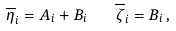<formula> <loc_0><loc_0><loc_500><loc_500>\overline { \eta } _ { i } = A _ { i } + B _ { i } \quad \overline { \zeta } _ { i } = B _ { i } \, ,</formula> 